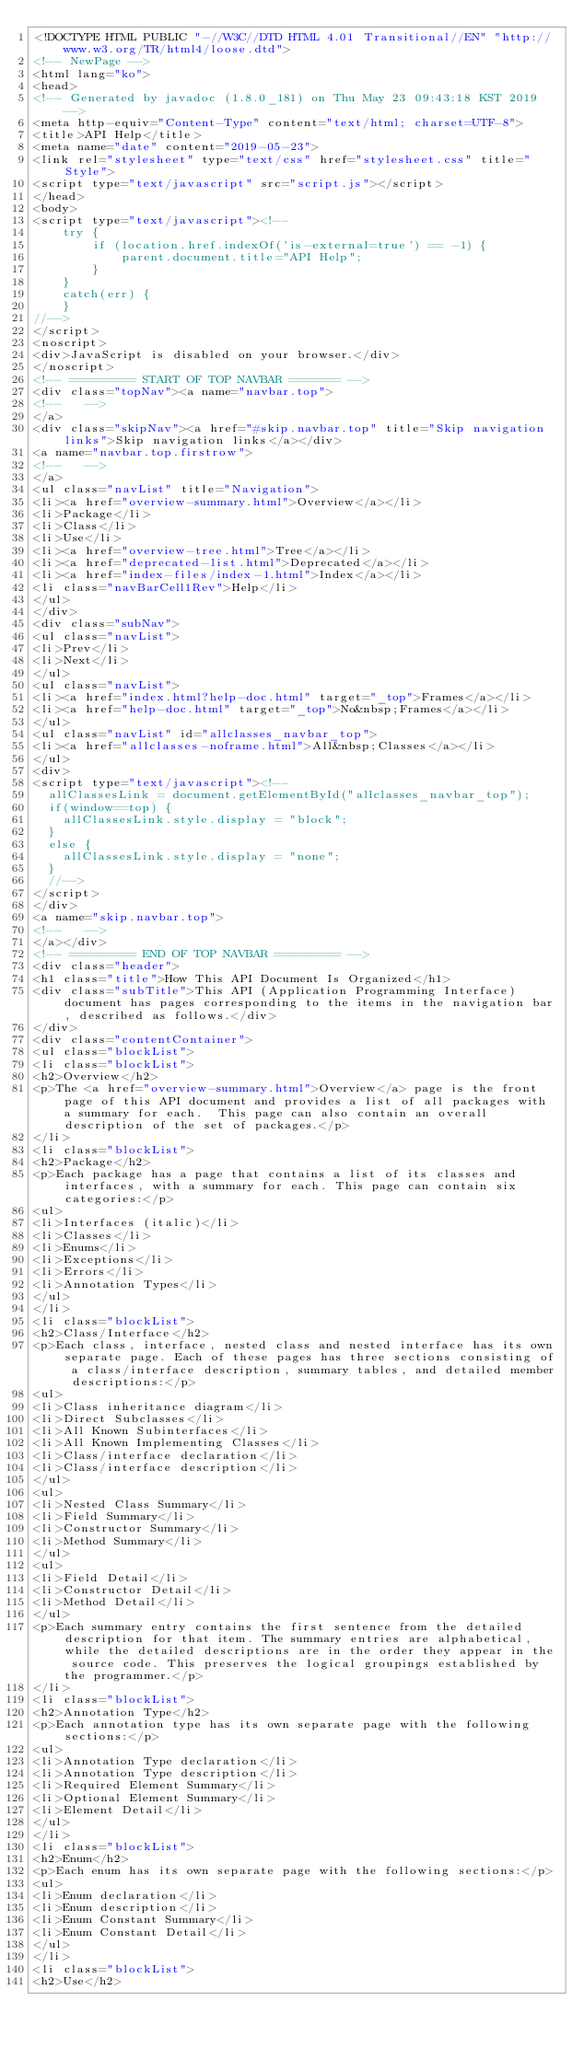<code> <loc_0><loc_0><loc_500><loc_500><_HTML_><!DOCTYPE HTML PUBLIC "-//W3C//DTD HTML 4.01 Transitional//EN" "http://www.w3.org/TR/html4/loose.dtd">
<!-- NewPage -->
<html lang="ko">
<head>
<!-- Generated by javadoc (1.8.0_181) on Thu May 23 09:43:18 KST 2019 -->
<meta http-equiv="Content-Type" content="text/html; charset=UTF-8">
<title>API Help</title>
<meta name="date" content="2019-05-23">
<link rel="stylesheet" type="text/css" href="stylesheet.css" title="Style">
<script type="text/javascript" src="script.js"></script>
</head>
<body>
<script type="text/javascript"><!--
    try {
        if (location.href.indexOf('is-external=true') == -1) {
            parent.document.title="API Help";
        }
    }
    catch(err) {
    }
//-->
</script>
<noscript>
<div>JavaScript is disabled on your browser.</div>
</noscript>
<!-- ========= START OF TOP NAVBAR ======= -->
<div class="topNav"><a name="navbar.top">
<!--   -->
</a>
<div class="skipNav"><a href="#skip.navbar.top" title="Skip navigation links">Skip navigation links</a></div>
<a name="navbar.top.firstrow">
<!--   -->
</a>
<ul class="navList" title="Navigation">
<li><a href="overview-summary.html">Overview</a></li>
<li>Package</li>
<li>Class</li>
<li>Use</li>
<li><a href="overview-tree.html">Tree</a></li>
<li><a href="deprecated-list.html">Deprecated</a></li>
<li><a href="index-files/index-1.html">Index</a></li>
<li class="navBarCell1Rev">Help</li>
</ul>
</div>
<div class="subNav">
<ul class="navList">
<li>Prev</li>
<li>Next</li>
</ul>
<ul class="navList">
<li><a href="index.html?help-doc.html" target="_top">Frames</a></li>
<li><a href="help-doc.html" target="_top">No&nbsp;Frames</a></li>
</ul>
<ul class="navList" id="allclasses_navbar_top">
<li><a href="allclasses-noframe.html">All&nbsp;Classes</a></li>
</ul>
<div>
<script type="text/javascript"><!--
  allClassesLink = document.getElementById("allclasses_navbar_top");
  if(window==top) {
    allClassesLink.style.display = "block";
  }
  else {
    allClassesLink.style.display = "none";
  }
  //-->
</script>
</div>
<a name="skip.navbar.top">
<!--   -->
</a></div>
<!-- ========= END OF TOP NAVBAR ========= -->
<div class="header">
<h1 class="title">How This API Document Is Organized</h1>
<div class="subTitle">This API (Application Programming Interface) document has pages corresponding to the items in the navigation bar, described as follows.</div>
</div>
<div class="contentContainer">
<ul class="blockList">
<li class="blockList">
<h2>Overview</h2>
<p>The <a href="overview-summary.html">Overview</a> page is the front page of this API document and provides a list of all packages with a summary for each.  This page can also contain an overall description of the set of packages.</p>
</li>
<li class="blockList">
<h2>Package</h2>
<p>Each package has a page that contains a list of its classes and interfaces, with a summary for each. This page can contain six categories:</p>
<ul>
<li>Interfaces (italic)</li>
<li>Classes</li>
<li>Enums</li>
<li>Exceptions</li>
<li>Errors</li>
<li>Annotation Types</li>
</ul>
</li>
<li class="blockList">
<h2>Class/Interface</h2>
<p>Each class, interface, nested class and nested interface has its own separate page. Each of these pages has three sections consisting of a class/interface description, summary tables, and detailed member descriptions:</p>
<ul>
<li>Class inheritance diagram</li>
<li>Direct Subclasses</li>
<li>All Known Subinterfaces</li>
<li>All Known Implementing Classes</li>
<li>Class/interface declaration</li>
<li>Class/interface description</li>
</ul>
<ul>
<li>Nested Class Summary</li>
<li>Field Summary</li>
<li>Constructor Summary</li>
<li>Method Summary</li>
</ul>
<ul>
<li>Field Detail</li>
<li>Constructor Detail</li>
<li>Method Detail</li>
</ul>
<p>Each summary entry contains the first sentence from the detailed description for that item. The summary entries are alphabetical, while the detailed descriptions are in the order they appear in the source code. This preserves the logical groupings established by the programmer.</p>
</li>
<li class="blockList">
<h2>Annotation Type</h2>
<p>Each annotation type has its own separate page with the following sections:</p>
<ul>
<li>Annotation Type declaration</li>
<li>Annotation Type description</li>
<li>Required Element Summary</li>
<li>Optional Element Summary</li>
<li>Element Detail</li>
</ul>
</li>
<li class="blockList">
<h2>Enum</h2>
<p>Each enum has its own separate page with the following sections:</p>
<ul>
<li>Enum declaration</li>
<li>Enum description</li>
<li>Enum Constant Summary</li>
<li>Enum Constant Detail</li>
</ul>
</li>
<li class="blockList">
<h2>Use</h2></code> 